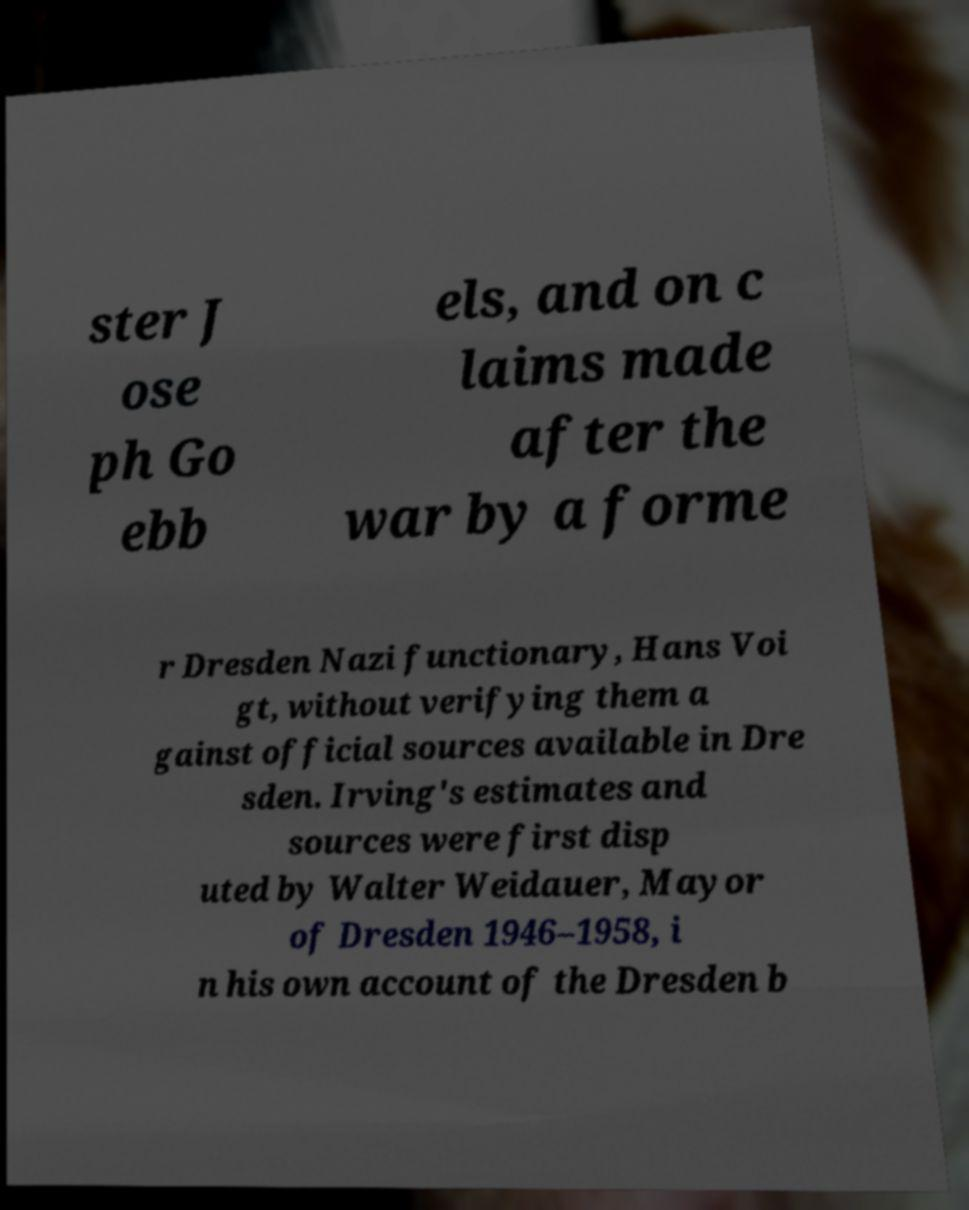Can you read and provide the text displayed in the image?This photo seems to have some interesting text. Can you extract and type it out for me? ster J ose ph Go ebb els, and on c laims made after the war by a forme r Dresden Nazi functionary, Hans Voi gt, without verifying them a gainst official sources available in Dre sden. Irving's estimates and sources were first disp uted by Walter Weidauer, Mayor of Dresden 1946–1958, i n his own account of the Dresden b 